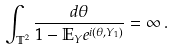Convert formula to latex. <formula><loc_0><loc_0><loc_500><loc_500>\int _ { { \mathbb { T } } ^ { 2 } } \frac { d \theta } { 1 - { \mathbb { E } } _ { Y } e ^ { i ( \theta , Y _ { 1 } ) } } = \infty \, .</formula> 